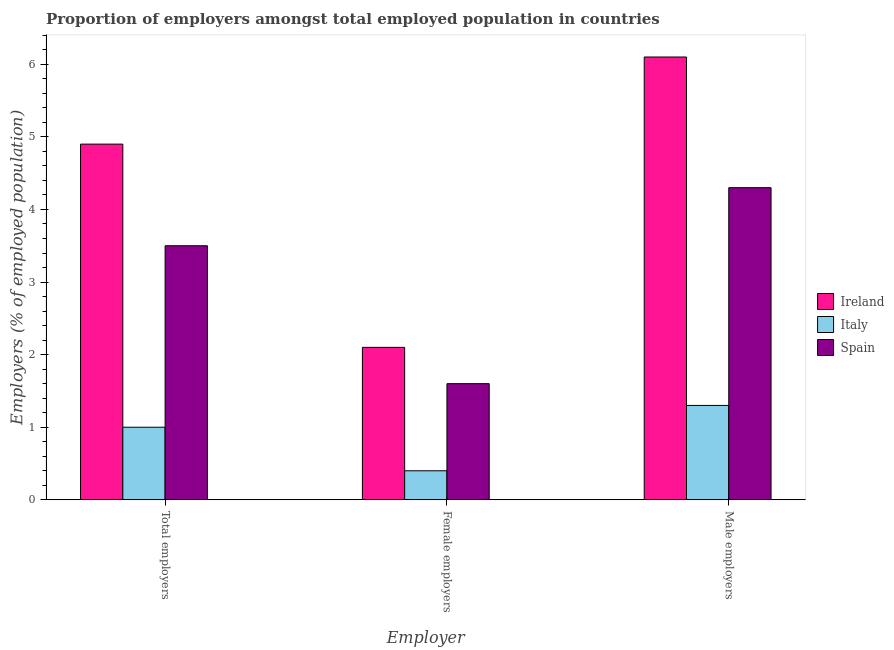How many different coloured bars are there?
Your answer should be compact. 3. How many groups of bars are there?
Make the answer very short. 3. What is the label of the 2nd group of bars from the left?
Offer a terse response. Female employers. What is the percentage of female employers in Italy?
Your answer should be very brief. 0.4. Across all countries, what is the maximum percentage of female employers?
Offer a terse response. 2.1. Across all countries, what is the minimum percentage of male employers?
Your answer should be compact. 1.3. In which country was the percentage of total employers maximum?
Your answer should be compact. Ireland. In which country was the percentage of female employers minimum?
Give a very brief answer. Italy. What is the total percentage of female employers in the graph?
Give a very brief answer. 4.1. What is the difference between the percentage of total employers in Italy and that in Ireland?
Your answer should be compact. -3.9. What is the difference between the percentage of female employers in Ireland and the percentage of male employers in Italy?
Keep it short and to the point. 0.8. What is the average percentage of total employers per country?
Keep it short and to the point. 3.13. What is the difference between the percentage of total employers and percentage of female employers in Spain?
Your answer should be compact. 1.9. What is the ratio of the percentage of female employers in Italy to that in Spain?
Your answer should be compact. 0.25. What is the difference between the highest and the second highest percentage of total employers?
Provide a succinct answer. 1.4. What is the difference between the highest and the lowest percentage of female employers?
Your response must be concise. 1.7. In how many countries, is the percentage of total employers greater than the average percentage of total employers taken over all countries?
Make the answer very short. 2. Is the sum of the percentage of total employers in Italy and Ireland greater than the maximum percentage of female employers across all countries?
Make the answer very short. Yes. What does the 1st bar from the left in Male employers represents?
Keep it short and to the point. Ireland. What does the 1st bar from the right in Female employers represents?
Make the answer very short. Spain. Is it the case that in every country, the sum of the percentage of total employers and percentage of female employers is greater than the percentage of male employers?
Give a very brief answer. Yes. How many countries are there in the graph?
Make the answer very short. 3. What is the difference between two consecutive major ticks on the Y-axis?
Make the answer very short. 1. Are the values on the major ticks of Y-axis written in scientific E-notation?
Your response must be concise. No. Does the graph contain grids?
Ensure brevity in your answer.  No. How many legend labels are there?
Give a very brief answer. 3. What is the title of the graph?
Ensure brevity in your answer.  Proportion of employers amongst total employed population in countries. What is the label or title of the X-axis?
Your answer should be very brief. Employer. What is the label or title of the Y-axis?
Your answer should be very brief. Employers (% of employed population). What is the Employers (% of employed population) in Ireland in Total employers?
Offer a terse response. 4.9. What is the Employers (% of employed population) of Ireland in Female employers?
Make the answer very short. 2.1. What is the Employers (% of employed population) in Italy in Female employers?
Provide a succinct answer. 0.4. What is the Employers (% of employed population) of Spain in Female employers?
Provide a succinct answer. 1.6. What is the Employers (% of employed population) in Ireland in Male employers?
Your answer should be compact. 6.1. What is the Employers (% of employed population) of Italy in Male employers?
Your answer should be very brief. 1.3. What is the Employers (% of employed population) in Spain in Male employers?
Ensure brevity in your answer.  4.3. Across all Employer, what is the maximum Employers (% of employed population) in Ireland?
Keep it short and to the point. 6.1. Across all Employer, what is the maximum Employers (% of employed population) in Italy?
Your answer should be compact. 1.3. Across all Employer, what is the maximum Employers (% of employed population) of Spain?
Ensure brevity in your answer.  4.3. Across all Employer, what is the minimum Employers (% of employed population) of Ireland?
Ensure brevity in your answer.  2.1. Across all Employer, what is the minimum Employers (% of employed population) of Italy?
Provide a short and direct response. 0.4. Across all Employer, what is the minimum Employers (% of employed population) of Spain?
Give a very brief answer. 1.6. What is the difference between the Employers (% of employed population) in Ireland in Total employers and that in Female employers?
Offer a very short reply. 2.8. What is the difference between the Employers (% of employed population) of Italy in Total employers and that in Female employers?
Your response must be concise. 0.6. What is the difference between the Employers (% of employed population) in Spain in Total employers and that in Female employers?
Your response must be concise. 1.9. What is the difference between the Employers (% of employed population) of Ireland in Total employers and that in Male employers?
Make the answer very short. -1.2. What is the difference between the Employers (% of employed population) in Italy in Total employers and that in Male employers?
Ensure brevity in your answer.  -0.3. What is the difference between the Employers (% of employed population) in Ireland in Female employers and that in Male employers?
Make the answer very short. -4. What is the difference between the Employers (% of employed population) in Italy in Female employers and that in Male employers?
Provide a short and direct response. -0.9. What is the difference between the Employers (% of employed population) in Ireland in Total employers and the Employers (% of employed population) in Spain in Female employers?
Your response must be concise. 3.3. What is the difference between the Employers (% of employed population) in Ireland in Total employers and the Employers (% of employed population) in Italy in Male employers?
Offer a terse response. 3.6. What is the difference between the Employers (% of employed population) in Italy in Total employers and the Employers (% of employed population) in Spain in Male employers?
Provide a short and direct response. -3.3. What is the difference between the Employers (% of employed population) of Ireland in Female employers and the Employers (% of employed population) of Spain in Male employers?
Your answer should be very brief. -2.2. What is the average Employers (% of employed population) in Ireland per Employer?
Your answer should be very brief. 4.37. What is the average Employers (% of employed population) of Spain per Employer?
Ensure brevity in your answer.  3.13. What is the difference between the Employers (% of employed population) of Ireland and Employers (% of employed population) of Italy in Total employers?
Your response must be concise. 3.9. What is the difference between the Employers (% of employed population) of Ireland and Employers (% of employed population) of Spain in Female employers?
Your answer should be compact. 0.5. What is the difference between the Employers (% of employed population) in Italy and Employers (% of employed population) in Spain in Female employers?
Your response must be concise. -1.2. What is the difference between the Employers (% of employed population) in Italy and Employers (% of employed population) in Spain in Male employers?
Offer a terse response. -3. What is the ratio of the Employers (% of employed population) in Ireland in Total employers to that in Female employers?
Provide a short and direct response. 2.33. What is the ratio of the Employers (% of employed population) in Italy in Total employers to that in Female employers?
Provide a succinct answer. 2.5. What is the ratio of the Employers (% of employed population) in Spain in Total employers to that in Female employers?
Provide a short and direct response. 2.19. What is the ratio of the Employers (% of employed population) of Ireland in Total employers to that in Male employers?
Your response must be concise. 0.8. What is the ratio of the Employers (% of employed population) of Italy in Total employers to that in Male employers?
Ensure brevity in your answer.  0.77. What is the ratio of the Employers (% of employed population) of Spain in Total employers to that in Male employers?
Your response must be concise. 0.81. What is the ratio of the Employers (% of employed population) in Ireland in Female employers to that in Male employers?
Your response must be concise. 0.34. What is the ratio of the Employers (% of employed population) in Italy in Female employers to that in Male employers?
Offer a very short reply. 0.31. What is the ratio of the Employers (% of employed population) in Spain in Female employers to that in Male employers?
Your answer should be compact. 0.37. What is the difference between the highest and the second highest Employers (% of employed population) in Italy?
Give a very brief answer. 0.3. What is the difference between the highest and the lowest Employers (% of employed population) of Italy?
Provide a short and direct response. 0.9. 